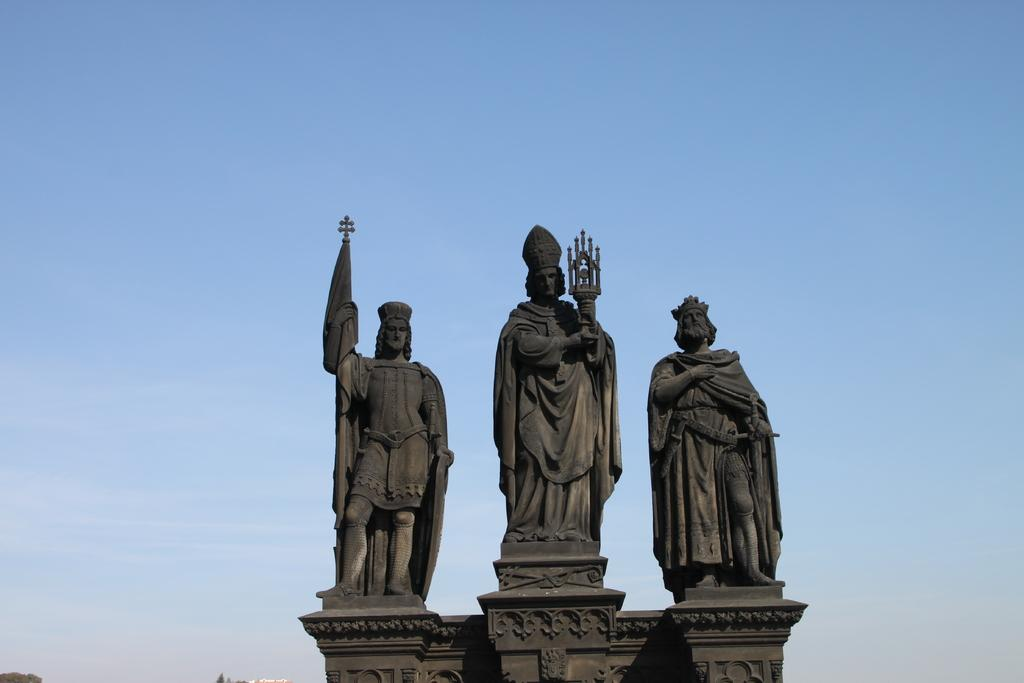How many statues are present in the image? There are three statues in the image. What is a common feature among the statues? Each statue has a crown. What are the statues holding in their hands? The statues are holding something. What can be seen in the background of the image? There is sky visible in the background of the image. What type of exchange is taking place between the statues in the image? There is no exchange taking place between the statues in the image; they are simply standing with their respective objects. 